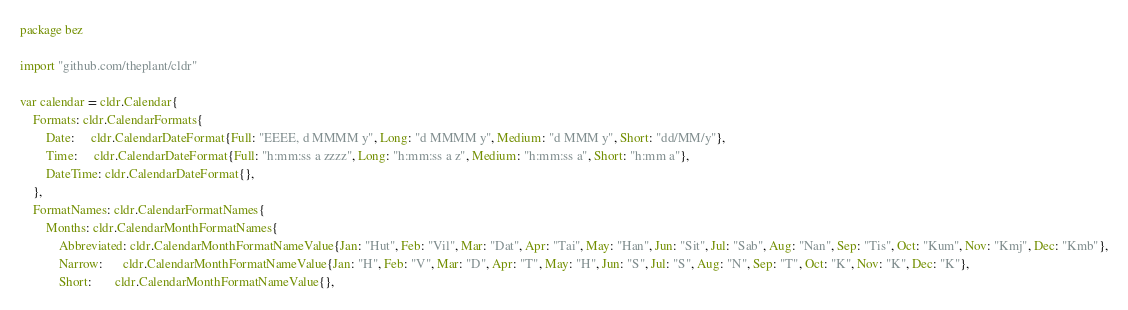<code> <loc_0><loc_0><loc_500><loc_500><_Go_>package bez

import "github.com/theplant/cldr"

var calendar = cldr.Calendar{
	Formats: cldr.CalendarFormats{
		Date:     cldr.CalendarDateFormat{Full: "EEEE, d MMMM y", Long: "d MMMM y", Medium: "d MMM y", Short: "dd/MM/y"},
		Time:     cldr.CalendarDateFormat{Full: "h:mm:ss a zzzz", Long: "h:mm:ss a z", Medium: "h:mm:ss a", Short: "h:mm a"},
		DateTime: cldr.CalendarDateFormat{},
	},
	FormatNames: cldr.CalendarFormatNames{
		Months: cldr.CalendarMonthFormatNames{
			Abbreviated: cldr.CalendarMonthFormatNameValue{Jan: "Hut", Feb: "Vil", Mar: "Dat", Apr: "Tai", May: "Han", Jun: "Sit", Jul: "Sab", Aug: "Nan", Sep: "Tis", Oct: "Kum", Nov: "Kmj", Dec: "Kmb"},
			Narrow:      cldr.CalendarMonthFormatNameValue{Jan: "H", Feb: "V", Mar: "D", Apr: "T", May: "H", Jun: "S", Jul: "S", Aug: "N", Sep: "T", Oct: "K", Nov: "K", Dec: "K"},
			Short:       cldr.CalendarMonthFormatNameValue{},</code> 